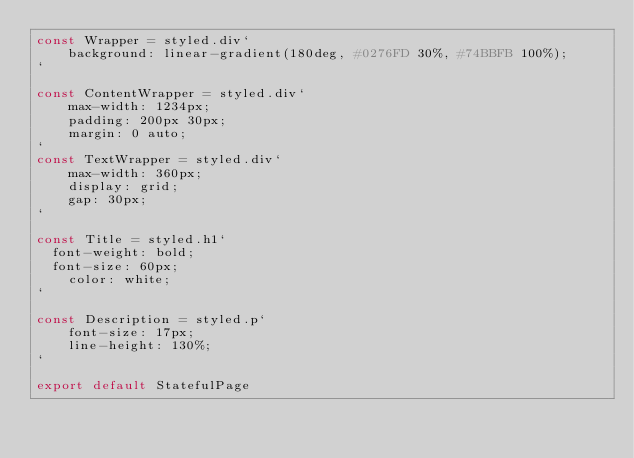<code> <loc_0><loc_0><loc_500><loc_500><_JavaScript_>const Wrapper = styled.div`
    background: linear-gradient(180deg, #0276FD 30%, #74BBFB 100%);
`

const ContentWrapper = styled.div`
	max-width: 1234px;
	padding: 200px 30px;
	margin: 0 auto;
`
const TextWrapper = styled.div`
    max-width: 360px;
    display: grid;
    gap: 30px;
`

const Title = styled.h1`
  font-weight: bold;
  font-size: 60px;
	color: white;
`

const Description = styled.p`
    font-size: 17px;
    line-height: 130%;
`

export default StatefulPage</code> 